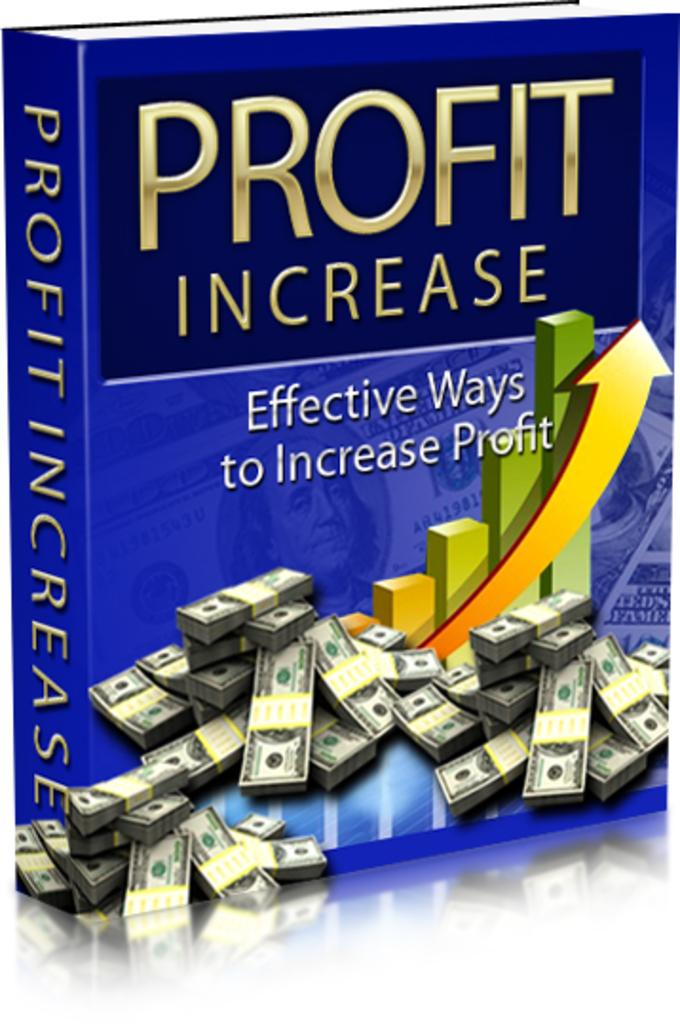<image>
Render a clear and concise summary of the photo. A blue book titled Profit Increase is on a white background. 